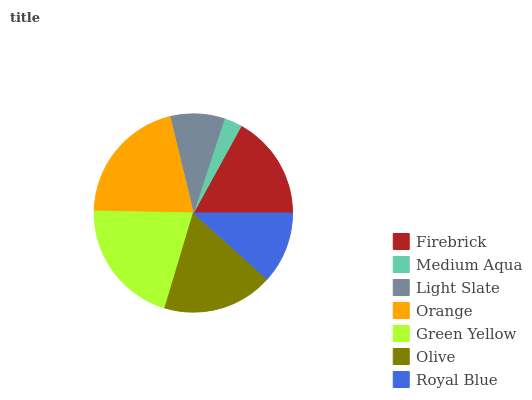Is Medium Aqua the minimum?
Answer yes or no. Yes. Is Orange the maximum?
Answer yes or no. Yes. Is Light Slate the minimum?
Answer yes or no. No. Is Light Slate the maximum?
Answer yes or no. No. Is Light Slate greater than Medium Aqua?
Answer yes or no. Yes. Is Medium Aqua less than Light Slate?
Answer yes or no. Yes. Is Medium Aqua greater than Light Slate?
Answer yes or no. No. Is Light Slate less than Medium Aqua?
Answer yes or no. No. Is Firebrick the high median?
Answer yes or no. Yes. Is Firebrick the low median?
Answer yes or no. Yes. Is Orange the high median?
Answer yes or no. No. Is Green Yellow the low median?
Answer yes or no. No. 